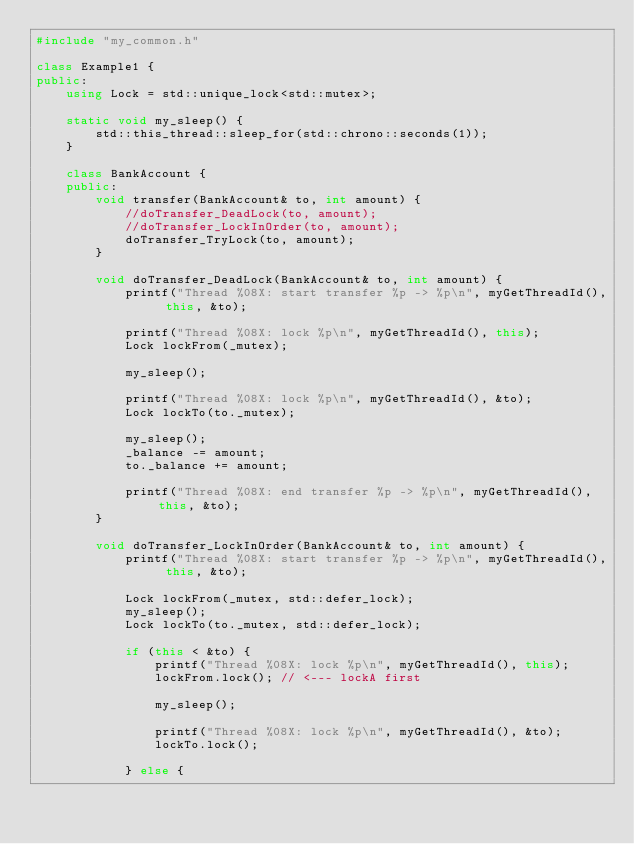<code> <loc_0><loc_0><loc_500><loc_500><_C++_>#include "my_common.h"

class Example1 {
public:
	using Lock = std::unique_lock<std::mutex>;

	static void my_sleep() {
		std::this_thread::sleep_for(std::chrono::seconds(1));
	}

	class BankAccount {
	public:
		void transfer(BankAccount& to, int amount) {
			//doTransfer_DeadLock(to, amount);
			//doTransfer_LockInOrder(to, amount);
			doTransfer_TryLock(to, amount);
		}

		void doTransfer_DeadLock(BankAccount& to, int amount) {
			printf("Thread %08X: start transfer %p -> %p\n", myGetThreadId(), this, &to);

			printf("Thread %08X: lock %p\n", myGetThreadId(), this);
			Lock lockFrom(_mutex);

			my_sleep();

			printf("Thread %08X: lock %p\n", myGetThreadId(), &to);
			Lock lockTo(to._mutex);

			my_sleep();
			_balance -= amount;
			to._balance += amount;

			printf("Thread %08X: end transfer %p -> %p\n", myGetThreadId(), this, &to);
		}

		void doTransfer_LockInOrder(BankAccount& to, int amount) {
			printf("Thread %08X: start transfer %p -> %p\n", myGetThreadId(), this, &to);

			Lock lockFrom(_mutex, std::defer_lock);
			my_sleep();
			Lock lockTo(to._mutex, std::defer_lock);

			if (this < &to) {
				printf("Thread %08X: lock %p\n", myGetThreadId(), this);
				lockFrom.lock(); // <--- lockA first

				my_sleep();

				printf("Thread %08X: lock %p\n", myGetThreadId(), &to);
				lockTo.lock();

			} else {</code> 